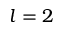Convert formula to latex. <formula><loc_0><loc_0><loc_500><loc_500>l = 2</formula> 